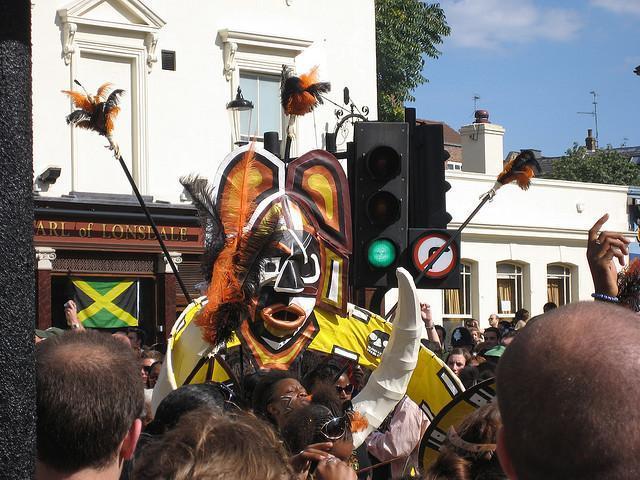How many people are in the photo?
Give a very brief answer. 5. How many traffic lights are visible?
Give a very brief answer. 2. How many white remotes do you see?
Give a very brief answer. 0. 